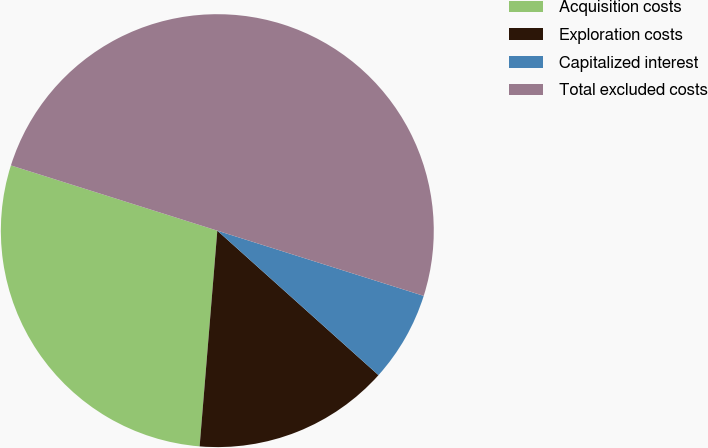Convert chart. <chart><loc_0><loc_0><loc_500><loc_500><pie_chart><fcel>Acquisition costs<fcel>Exploration costs<fcel>Capitalized interest<fcel>Total excluded costs<nl><fcel>28.57%<fcel>14.67%<fcel>6.76%<fcel>50.0%<nl></chart> 